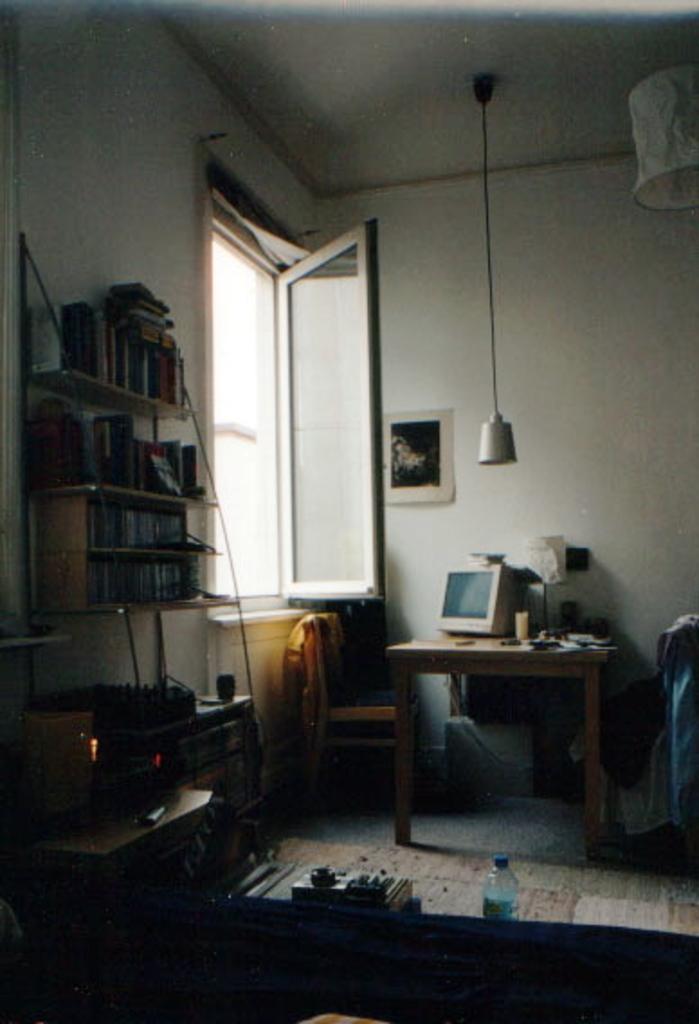Can you describe this image briefly? As we can see in the image there is a wall, window, shelves, table, bottle, switch board and screen. 